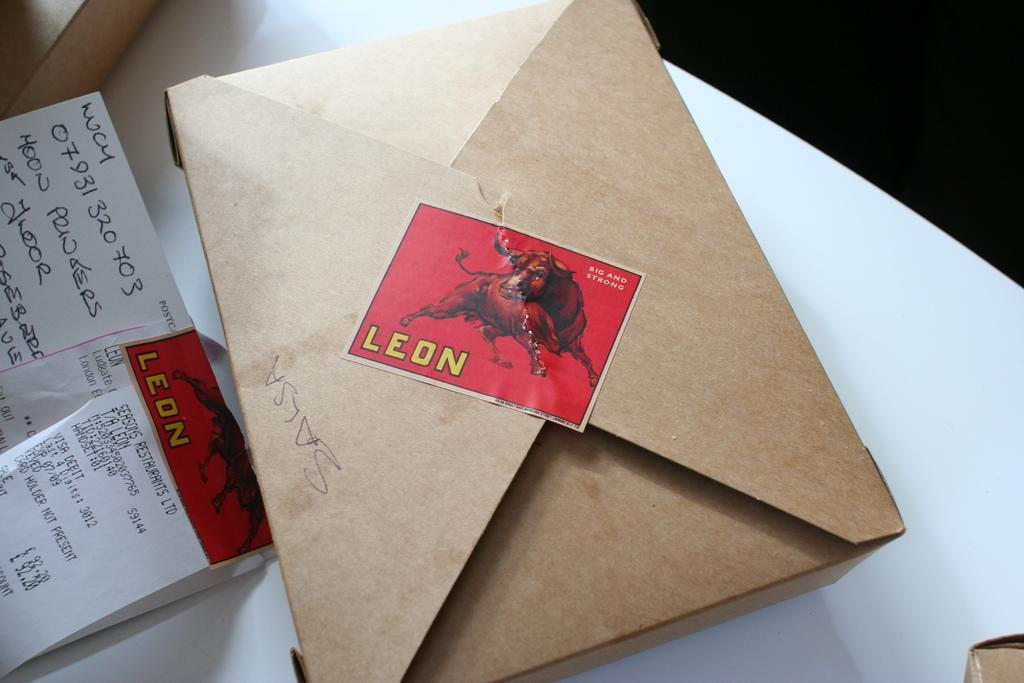<image>
Create a compact narrative representing the image presented. A brown box food container with a sticker of a bull on it and the word Leon below it 